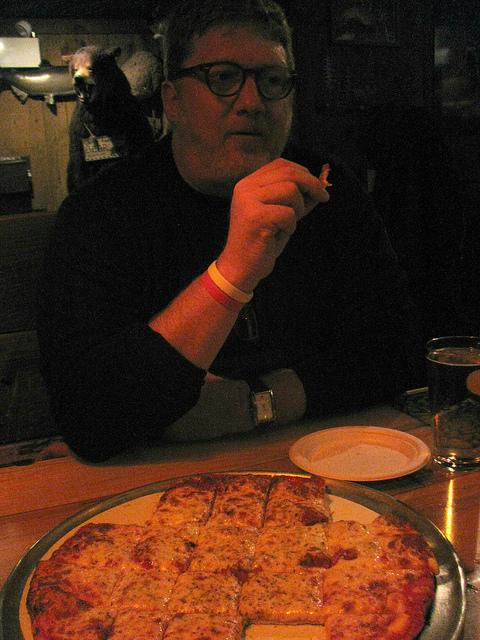What animal is in the background?
Short answer required. Bear. Does the person have 20/20 vision?
Write a very short answer. No. What kind of food is in front of him?
Quick response, please. Pizza. 